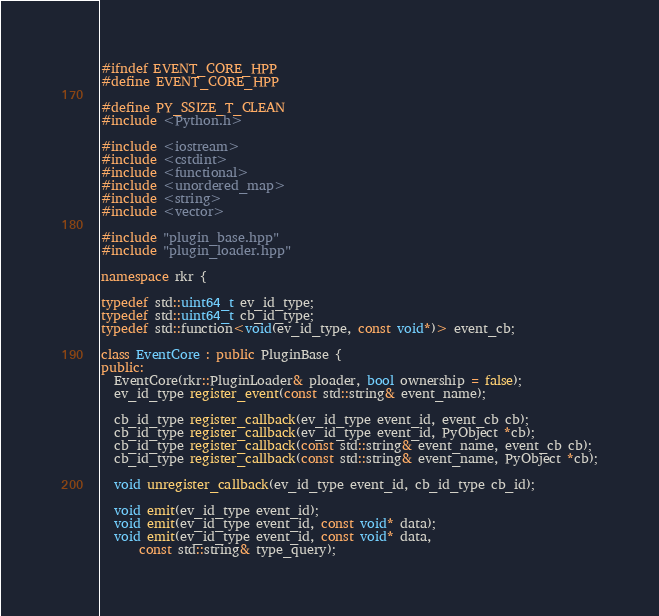Convert code to text. <code><loc_0><loc_0><loc_500><loc_500><_C++_>#ifndef EVENT_CORE_HPP
#define EVENT_CORE_HPP

#define PY_SSIZE_T_CLEAN
#include <Python.h>

#include <iostream>
#include <cstdint>
#include <functional>
#include <unordered_map>
#include <string>
#include <vector>

#include "plugin_base.hpp"
#include "plugin_loader.hpp"

namespace rkr {

typedef std::uint64_t ev_id_type;
typedef std::uint64_t cb_id_type;
typedef std::function<void(ev_id_type, const void*)> event_cb;

class EventCore : public PluginBase {
public:
  EventCore(rkr::PluginLoader& ploader, bool ownership = false);
  ev_id_type register_event(const std::string& event_name);

  cb_id_type register_callback(ev_id_type event_id, event_cb cb);
  cb_id_type register_callback(ev_id_type event_id, PyObject *cb);
  cb_id_type register_callback(const std::string& event_name, event_cb cb);
  cb_id_type register_callback(const std::string& event_name, PyObject *cb);

  void unregister_callback(ev_id_type event_id, cb_id_type cb_id);

  void emit(ev_id_type event_id);
  void emit(ev_id_type event_id, const void* data);
  void emit(ev_id_type event_id, const void* data,
      const std::string& type_query);</code> 